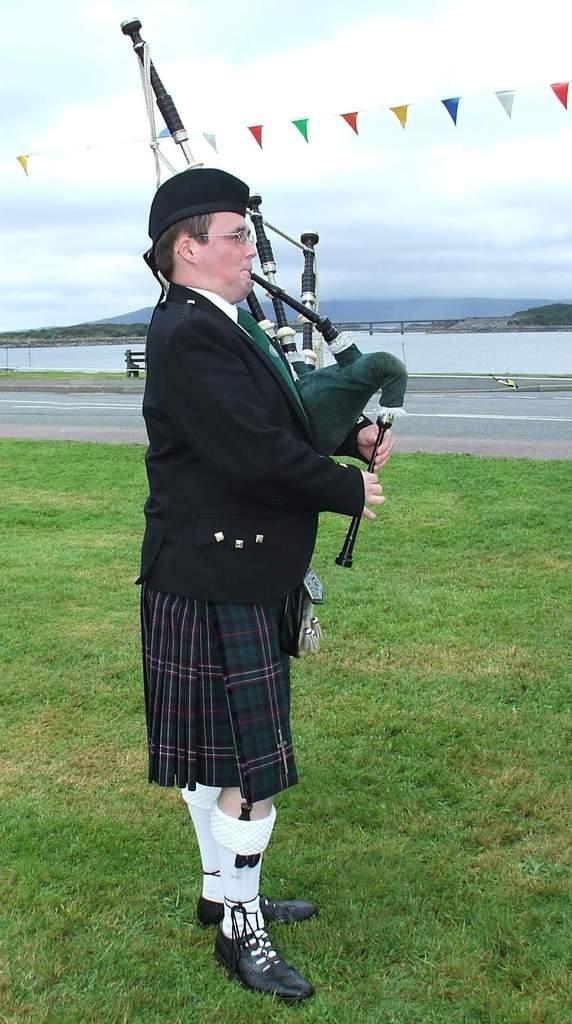How would you summarize this image in a sentence or two? In the middle of the image we can see a man, he wore spectacles and a cap, and he is playing a musical instrument, in the background we can see few flags, a bench, trees and a bridge over the water, and he is standing on the grass. 